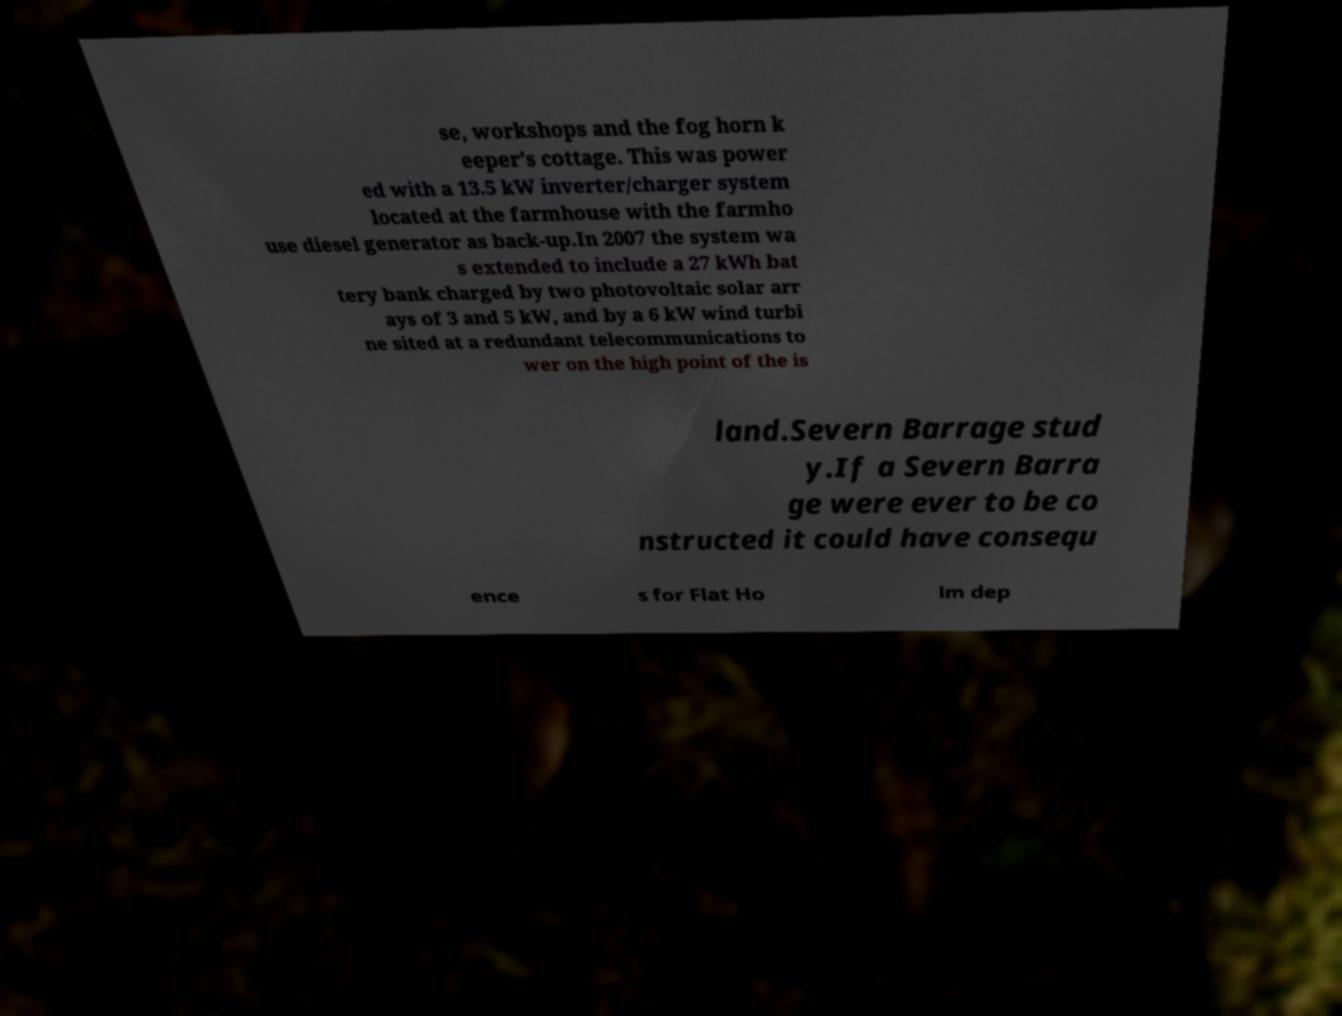Can you accurately transcribe the text from the provided image for me? se, workshops and the fog horn k eeper's cottage. This was power ed with a 13.5 kW inverter/charger system located at the farmhouse with the farmho use diesel generator as back-up.In 2007 the system wa s extended to include a 27 kWh bat tery bank charged by two photovoltaic solar arr ays of 3 and 5 kW, and by a 6 kW wind turbi ne sited at a redundant telecommunications to wer on the high point of the is land.Severn Barrage stud y.If a Severn Barra ge were ever to be co nstructed it could have consequ ence s for Flat Ho lm dep 